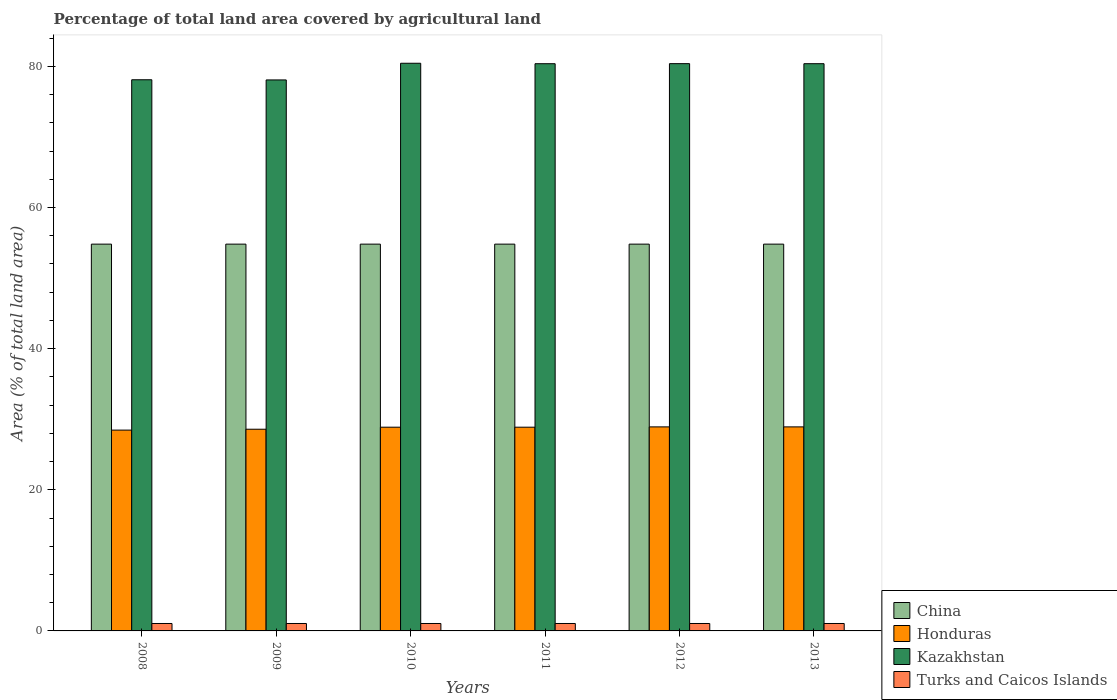How many different coloured bars are there?
Provide a short and direct response. 4. How many groups of bars are there?
Provide a succinct answer. 6. Are the number of bars per tick equal to the number of legend labels?
Give a very brief answer. Yes. In how many cases, is the number of bars for a given year not equal to the number of legend labels?
Your answer should be very brief. 0. What is the percentage of agricultural land in Kazakhstan in 2009?
Your response must be concise. 78.08. Across all years, what is the maximum percentage of agricultural land in China?
Make the answer very short. 54.81. Across all years, what is the minimum percentage of agricultural land in Honduras?
Ensure brevity in your answer.  28.46. What is the total percentage of agricultural land in Kazakhstan in the graph?
Your answer should be very brief. 477.75. What is the difference between the percentage of agricultural land in Kazakhstan in 2012 and the percentage of agricultural land in China in 2013?
Your answer should be compact. 25.58. What is the average percentage of agricultural land in Turks and Caicos Islands per year?
Provide a succinct answer. 1.05. In the year 2009, what is the difference between the percentage of agricultural land in Honduras and percentage of agricultural land in Kazakhstan?
Ensure brevity in your answer.  -49.49. In how many years, is the percentage of agricultural land in Honduras greater than 16 %?
Your answer should be very brief. 6. What is the ratio of the percentage of agricultural land in China in 2009 to that in 2012?
Your answer should be very brief. 1. Is the percentage of agricultural land in Turks and Caicos Islands in 2009 less than that in 2010?
Your response must be concise. No. What is the difference between the highest and the second highest percentage of agricultural land in Honduras?
Keep it short and to the point. 0. What is the difference between the highest and the lowest percentage of agricultural land in Kazakhstan?
Provide a succinct answer. 2.36. What does the 3rd bar from the left in 2009 represents?
Offer a very short reply. Kazakhstan. What does the 1st bar from the right in 2011 represents?
Your answer should be compact. Turks and Caicos Islands. How many bars are there?
Keep it short and to the point. 24. Are all the bars in the graph horizontal?
Make the answer very short. No. What is the difference between two consecutive major ticks on the Y-axis?
Your response must be concise. 20. Are the values on the major ticks of Y-axis written in scientific E-notation?
Your answer should be compact. No. Where does the legend appear in the graph?
Keep it short and to the point. Bottom right. How are the legend labels stacked?
Your response must be concise. Vertical. What is the title of the graph?
Make the answer very short. Percentage of total land area covered by agricultural land. Does "Luxembourg" appear as one of the legend labels in the graph?
Your response must be concise. No. What is the label or title of the X-axis?
Give a very brief answer. Years. What is the label or title of the Y-axis?
Give a very brief answer. Area (% of total land area). What is the Area (% of total land area) of China in 2008?
Keep it short and to the point. 54.81. What is the Area (% of total land area) in Honduras in 2008?
Offer a very short reply. 28.46. What is the Area (% of total land area) of Kazakhstan in 2008?
Your answer should be very brief. 78.1. What is the Area (% of total land area) in Turks and Caicos Islands in 2008?
Provide a succinct answer. 1.05. What is the Area (% of total land area) of China in 2009?
Ensure brevity in your answer.  54.81. What is the Area (% of total land area) of Honduras in 2009?
Keep it short and to the point. 28.58. What is the Area (% of total land area) in Kazakhstan in 2009?
Your response must be concise. 78.08. What is the Area (% of total land area) in Turks and Caicos Islands in 2009?
Offer a very short reply. 1.05. What is the Area (% of total land area) in China in 2010?
Offer a very short reply. 54.81. What is the Area (% of total land area) of Honduras in 2010?
Your answer should be compact. 28.87. What is the Area (% of total land area) of Kazakhstan in 2010?
Offer a terse response. 80.44. What is the Area (% of total land area) in Turks and Caicos Islands in 2010?
Give a very brief answer. 1.05. What is the Area (% of total land area) in China in 2011?
Keep it short and to the point. 54.81. What is the Area (% of total land area) of Honduras in 2011?
Offer a very short reply. 28.87. What is the Area (% of total land area) in Kazakhstan in 2011?
Provide a succinct answer. 80.38. What is the Area (% of total land area) in Turks and Caicos Islands in 2011?
Offer a terse response. 1.05. What is the Area (% of total land area) of China in 2012?
Keep it short and to the point. 54.81. What is the Area (% of total land area) of Honduras in 2012?
Your answer should be very brief. 28.91. What is the Area (% of total land area) in Kazakhstan in 2012?
Keep it short and to the point. 80.38. What is the Area (% of total land area) in Turks and Caicos Islands in 2012?
Give a very brief answer. 1.05. What is the Area (% of total land area) in China in 2013?
Provide a succinct answer. 54.81. What is the Area (% of total land area) of Honduras in 2013?
Make the answer very short. 28.91. What is the Area (% of total land area) of Kazakhstan in 2013?
Make the answer very short. 80.38. What is the Area (% of total land area) in Turks and Caicos Islands in 2013?
Ensure brevity in your answer.  1.05. Across all years, what is the maximum Area (% of total land area) in China?
Your answer should be compact. 54.81. Across all years, what is the maximum Area (% of total land area) in Honduras?
Offer a terse response. 28.91. Across all years, what is the maximum Area (% of total land area) of Kazakhstan?
Give a very brief answer. 80.44. Across all years, what is the maximum Area (% of total land area) of Turks and Caicos Islands?
Your answer should be compact. 1.05. Across all years, what is the minimum Area (% of total land area) in China?
Your answer should be compact. 54.81. Across all years, what is the minimum Area (% of total land area) in Honduras?
Provide a short and direct response. 28.46. Across all years, what is the minimum Area (% of total land area) of Kazakhstan?
Your response must be concise. 78.08. Across all years, what is the minimum Area (% of total land area) in Turks and Caicos Islands?
Offer a terse response. 1.05. What is the total Area (% of total land area) of China in the graph?
Ensure brevity in your answer.  328.85. What is the total Area (% of total land area) in Honduras in the graph?
Ensure brevity in your answer.  172.6. What is the total Area (% of total land area) in Kazakhstan in the graph?
Your response must be concise. 477.75. What is the total Area (% of total land area) in Turks and Caicos Islands in the graph?
Offer a terse response. 6.32. What is the difference between the Area (% of total land area) in China in 2008 and that in 2009?
Make the answer very short. -0. What is the difference between the Area (% of total land area) in Honduras in 2008 and that in 2009?
Keep it short and to the point. -0.13. What is the difference between the Area (% of total land area) of Kazakhstan in 2008 and that in 2009?
Provide a short and direct response. 0.03. What is the difference between the Area (% of total land area) of China in 2008 and that in 2010?
Keep it short and to the point. -0. What is the difference between the Area (% of total land area) in Honduras in 2008 and that in 2010?
Provide a short and direct response. -0.41. What is the difference between the Area (% of total land area) in Kazakhstan in 2008 and that in 2010?
Offer a very short reply. -2.34. What is the difference between the Area (% of total land area) of China in 2008 and that in 2011?
Provide a short and direct response. -0. What is the difference between the Area (% of total land area) in Honduras in 2008 and that in 2011?
Offer a terse response. -0.41. What is the difference between the Area (% of total land area) in Kazakhstan in 2008 and that in 2011?
Offer a very short reply. -2.27. What is the difference between the Area (% of total land area) in Turks and Caicos Islands in 2008 and that in 2011?
Ensure brevity in your answer.  0. What is the difference between the Area (% of total land area) of China in 2008 and that in 2012?
Give a very brief answer. -0. What is the difference between the Area (% of total land area) of Honduras in 2008 and that in 2012?
Your answer should be very brief. -0.46. What is the difference between the Area (% of total land area) in Kazakhstan in 2008 and that in 2012?
Give a very brief answer. -2.28. What is the difference between the Area (% of total land area) in China in 2008 and that in 2013?
Offer a terse response. -0. What is the difference between the Area (% of total land area) of Honduras in 2008 and that in 2013?
Provide a short and direct response. -0.46. What is the difference between the Area (% of total land area) in Kazakhstan in 2008 and that in 2013?
Your answer should be very brief. -2.28. What is the difference between the Area (% of total land area) of China in 2009 and that in 2010?
Provide a short and direct response. 0. What is the difference between the Area (% of total land area) of Honduras in 2009 and that in 2010?
Give a very brief answer. -0.29. What is the difference between the Area (% of total land area) of Kazakhstan in 2009 and that in 2010?
Your answer should be compact. -2.36. What is the difference between the Area (% of total land area) of Honduras in 2009 and that in 2011?
Offer a very short reply. -0.29. What is the difference between the Area (% of total land area) of Kazakhstan in 2009 and that in 2011?
Give a very brief answer. -2.3. What is the difference between the Area (% of total land area) in Turks and Caicos Islands in 2009 and that in 2011?
Make the answer very short. 0. What is the difference between the Area (% of total land area) of Honduras in 2009 and that in 2012?
Provide a succinct answer. -0.33. What is the difference between the Area (% of total land area) of Kazakhstan in 2009 and that in 2012?
Provide a succinct answer. -2.31. What is the difference between the Area (% of total land area) in China in 2009 and that in 2013?
Give a very brief answer. 0. What is the difference between the Area (% of total land area) of Honduras in 2009 and that in 2013?
Your response must be concise. -0.33. What is the difference between the Area (% of total land area) in Kazakhstan in 2009 and that in 2013?
Provide a short and direct response. -2.3. What is the difference between the Area (% of total land area) of Turks and Caicos Islands in 2009 and that in 2013?
Your answer should be very brief. 0. What is the difference between the Area (% of total land area) in China in 2010 and that in 2011?
Give a very brief answer. -0. What is the difference between the Area (% of total land area) in Honduras in 2010 and that in 2011?
Your answer should be very brief. 0. What is the difference between the Area (% of total land area) of Kazakhstan in 2010 and that in 2011?
Your answer should be very brief. 0.06. What is the difference between the Area (% of total land area) in China in 2010 and that in 2012?
Your answer should be very brief. -0. What is the difference between the Area (% of total land area) in Honduras in 2010 and that in 2012?
Give a very brief answer. -0.04. What is the difference between the Area (% of total land area) of Kazakhstan in 2010 and that in 2012?
Ensure brevity in your answer.  0.06. What is the difference between the Area (% of total land area) in Turks and Caicos Islands in 2010 and that in 2012?
Keep it short and to the point. 0. What is the difference between the Area (% of total land area) in China in 2010 and that in 2013?
Offer a terse response. -0. What is the difference between the Area (% of total land area) of Honduras in 2010 and that in 2013?
Ensure brevity in your answer.  -0.04. What is the difference between the Area (% of total land area) of Kazakhstan in 2010 and that in 2013?
Ensure brevity in your answer.  0.06. What is the difference between the Area (% of total land area) of Turks and Caicos Islands in 2010 and that in 2013?
Ensure brevity in your answer.  0. What is the difference between the Area (% of total land area) in China in 2011 and that in 2012?
Provide a succinct answer. 0. What is the difference between the Area (% of total land area) in Honduras in 2011 and that in 2012?
Your answer should be very brief. -0.04. What is the difference between the Area (% of total land area) in Kazakhstan in 2011 and that in 2012?
Ensure brevity in your answer.  -0.01. What is the difference between the Area (% of total land area) in Turks and Caicos Islands in 2011 and that in 2012?
Your answer should be compact. 0. What is the difference between the Area (% of total land area) in Honduras in 2011 and that in 2013?
Provide a succinct answer. -0.04. What is the difference between the Area (% of total land area) in Kazakhstan in 2011 and that in 2013?
Ensure brevity in your answer.  -0. What is the difference between the Area (% of total land area) of Turks and Caicos Islands in 2011 and that in 2013?
Provide a succinct answer. 0. What is the difference between the Area (% of total land area) of Kazakhstan in 2012 and that in 2013?
Your answer should be very brief. 0.01. What is the difference between the Area (% of total land area) of Turks and Caicos Islands in 2012 and that in 2013?
Offer a terse response. 0. What is the difference between the Area (% of total land area) in China in 2008 and the Area (% of total land area) in Honduras in 2009?
Provide a short and direct response. 26.23. What is the difference between the Area (% of total land area) of China in 2008 and the Area (% of total land area) of Kazakhstan in 2009?
Provide a short and direct response. -23.27. What is the difference between the Area (% of total land area) of China in 2008 and the Area (% of total land area) of Turks and Caicos Islands in 2009?
Make the answer very short. 53.76. What is the difference between the Area (% of total land area) of Honduras in 2008 and the Area (% of total land area) of Kazakhstan in 2009?
Provide a short and direct response. -49.62. What is the difference between the Area (% of total land area) of Honduras in 2008 and the Area (% of total land area) of Turks and Caicos Islands in 2009?
Keep it short and to the point. 27.4. What is the difference between the Area (% of total land area) in Kazakhstan in 2008 and the Area (% of total land area) in Turks and Caicos Islands in 2009?
Your answer should be very brief. 77.05. What is the difference between the Area (% of total land area) of China in 2008 and the Area (% of total land area) of Honduras in 2010?
Offer a very short reply. 25.94. What is the difference between the Area (% of total land area) in China in 2008 and the Area (% of total land area) in Kazakhstan in 2010?
Keep it short and to the point. -25.63. What is the difference between the Area (% of total land area) in China in 2008 and the Area (% of total land area) in Turks and Caicos Islands in 2010?
Your answer should be very brief. 53.76. What is the difference between the Area (% of total land area) of Honduras in 2008 and the Area (% of total land area) of Kazakhstan in 2010?
Offer a terse response. -51.98. What is the difference between the Area (% of total land area) of Honduras in 2008 and the Area (% of total land area) of Turks and Caicos Islands in 2010?
Your response must be concise. 27.4. What is the difference between the Area (% of total land area) of Kazakhstan in 2008 and the Area (% of total land area) of Turks and Caicos Islands in 2010?
Make the answer very short. 77.05. What is the difference between the Area (% of total land area) of China in 2008 and the Area (% of total land area) of Honduras in 2011?
Your answer should be compact. 25.94. What is the difference between the Area (% of total land area) in China in 2008 and the Area (% of total land area) in Kazakhstan in 2011?
Give a very brief answer. -25.57. What is the difference between the Area (% of total land area) in China in 2008 and the Area (% of total land area) in Turks and Caicos Islands in 2011?
Give a very brief answer. 53.76. What is the difference between the Area (% of total land area) in Honduras in 2008 and the Area (% of total land area) in Kazakhstan in 2011?
Offer a very short reply. -51.92. What is the difference between the Area (% of total land area) of Honduras in 2008 and the Area (% of total land area) of Turks and Caicos Islands in 2011?
Give a very brief answer. 27.4. What is the difference between the Area (% of total land area) in Kazakhstan in 2008 and the Area (% of total land area) in Turks and Caicos Islands in 2011?
Offer a very short reply. 77.05. What is the difference between the Area (% of total land area) of China in 2008 and the Area (% of total land area) of Honduras in 2012?
Provide a succinct answer. 25.9. What is the difference between the Area (% of total land area) in China in 2008 and the Area (% of total land area) in Kazakhstan in 2012?
Your response must be concise. -25.58. What is the difference between the Area (% of total land area) of China in 2008 and the Area (% of total land area) of Turks and Caicos Islands in 2012?
Keep it short and to the point. 53.76. What is the difference between the Area (% of total land area) of Honduras in 2008 and the Area (% of total land area) of Kazakhstan in 2012?
Your answer should be compact. -51.93. What is the difference between the Area (% of total land area) in Honduras in 2008 and the Area (% of total land area) in Turks and Caicos Islands in 2012?
Your response must be concise. 27.4. What is the difference between the Area (% of total land area) of Kazakhstan in 2008 and the Area (% of total land area) of Turks and Caicos Islands in 2012?
Provide a succinct answer. 77.05. What is the difference between the Area (% of total land area) of China in 2008 and the Area (% of total land area) of Honduras in 2013?
Provide a succinct answer. 25.9. What is the difference between the Area (% of total land area) of China in 2008 and the Area (% of total land area) of Kazakhstan in 2013?
Your response must be concise. -25.57. What is the difference between the Area (% of total land area) in China in 2008 and the Area (% of total land area) in Turks and Caicos Islands in 2013?
Make the answer very short. 53.76. What is the difference between the Area (% of total land area) of Honduras in 2008 and the Area (% of total land area) of Kazakhstan in 2013?
Make the answer very short. -51.92. What is the difference between the Area (% of total land area) in Honduras in 2008 and the Area (% of total land area) in Turks and Caicos Islands in 2013?
Make the answer very short. 27.4. What is the difference between the Area (% of total land area) in Kazakhstan in 2008 and the Area (% of total land area) in Turks and Caicos Islands in 2013?
Ensure brevity in your answer.  77.05. What is the difference between the Area (% of total land area) in China in 2009 and the Area (% of total land area) in Honduras in 2010?
Make the answer very short. 25.94. What is the difference between the Area (% of total land area) of China in 2009 and the Area (% of total land area) of Kazakhstan in 2010?
Offer a very short reply. -25.63. What is the difference between the Area (% of total land area) of China in 2009 and the Area (% of total land area) of Turks and Caicos Islands in 2010?
Keep it short and to the point. 53.76. What is the difference between the Area (% of total land area) in Honduras in 2009 and the Area (% of total land area) in Kazakhstan in 2010?
Keep it short and to the point. -51.86. What is the difference between the Area (% of total land area) in Honduras in 2009 and the Area (% of total land area) in Turks and Caicos Islands in 2010?
Ensure brevity in your answer.  27.53. What is the difference between the Area (% of total land area) of Kazakhstan in 2009 and the Area (% of total land area) of Turks and Caicos Islands in 2010?
Ensure brevity in your answer.  77.02. What is the difference between the Area (% of total land area) in China in 2009 and the Area (% of total land area) in Honduras in 2011?
Your response must be concise. 25.94. What is the difference between the Area (% of total land area) in China in 2009 and the Area (% of total land area) in Kazakhstan in 2011?
Provide a short and direct response. -25.57. What is the difference between the Area (% of total land area) of China in 2009 and the Area (% of total land area) of Turks and Caicos Islands in 2011?
Your answer should be very brief. 53.76. What is the difference between the Area (% of total land area) of Honduras in 2009 and the Area (% of total land area) of Kazakhstan in 2011?
Your answer should be compact. -51.79. What is the difference between the Area (% of total land area) of Honduras in 2009 and the Area (% of total land area) of Turks and Caicos Islands in 2011?
Your answer should be compact. 27.53. What is the difference between the Area (% of total land area) in Kazakhstan in 2009 and the Area (% of total land area) in Turks and Caicos Islands in 2011?
Make the answer very short. 77.02. What is the difference between the Area (% of total land area) of China in 2009 and the Area (% of total land area) of Honduras in 2012?
Make the answer very short. 25.9. What is the difference between the Area (% of total land area) in China in 2009 and the Area (% of total land area) in Kazakhstan in 2012?
Your answer should be compact. -25.58. What is the difference between the Area (% of total land area) in China in 2009 and the Area (% of total land area) in Turks and Caicos Islands in 2012?
Offer a very short reply. 53.76. What is the difference between the Area (% of total land area) in Honduras in 2009 and the Area (% of total land area) in Kazakhstan in 2012?
Offer a very short reply. -51.8. What is the difference between the Area (% of total land area) in Honduras in 2009 and the Area (% of total land area) in Turks and Caicos Islands in 2012?
Your answer should be compact. 27.53. What is the difference between the Area (% of total land area) in Kazakhstan in 2009 and the Area (% of total land area) in Turks and Caicos Islands in 2012?
Keep it short and to the point. 77.02. What is the difference between the Area (% of total land area) in China in 2009 and the Area (% of total land area) in Honduras in 2013?
Offer a very short reply. 25.9. What is the difference between the Area (% of total land area) of China in 2009 and the Area (% of total land area) of Kazakhstan in 2013?
Give a very brief answer. -25.57. What is the difference between the Area (% of total land area) in China in 2009 and the Area (% of total land area) in Turks and Caicos Islands in 2013?
Ensure brevity in your answer.  53.76. What is the difference between the Area (% of total land area) of Honduras in 2009 and the Area (% of total land area) of Kazakhstan in 2013?
Your answer should be compact. -51.8. What is the difference between the Area (% of total land area) of Honduras in 2009 and the Area (% of total land area) of Turks and Caicos Islands in 2013?
Offer a very short reply. 27.53. What is the difference between the Area (% of total land area) in Kazakhstan in 2009 and the Area (% of total land area) in Turks and Caicos Islands in 2013?
Provide a succinct answer. 77.02. What is the difference between the Area (% of total land area) in China in 2010 and the Area (% of total land area) in Honduras in 2011?
Provide a short and direct response. 25.94. What is the difference between the Area (% of total land area) in China in 2010 and the Area (% of total land area) in Kazakhstan in 2011?
Your answer should be very brief. -25.57. What is the difference between the Area (% of total land area) of China in 2010 and the Area (% of total land area) of Turks and Caicos Islands in 2011?
Your answer should be very brief. 53.76. What is the difference between the Area (% of total land area) of Honduras in 2010 and the Area (% of total land area) of Kazakhstan in 2011?
Provide a succinct answer. -51.51. What is the difference between the Area (% of total land area) of Honduras in 2010 and the Area (% of total land area) of Turks and Caicos Islands in 2011?
Provide a succinct answer. 27.82. What is the difference between the Area (% of total land area) in Kazakhstan in 2010 and the Area (% of total land area) in Turks and Caicos Islands in 2011?
Give a very brief answer. 79.39. What is the difference between the Area (% of total land area) in China in 2010 and the Area (% of total land area) in Honduras in 2012?
Provide a short and direct response. 25.9. What is the difference between the Area (% of total land area) in China in 2010 and the Area (% of total land area) in Kazakhstan in 2012?
Your answer should be very brief. -25.58. What is the difference between the Area (% of total land area) of China in 2010 and the Area (% of total land area) of Turks and Caicos Islands in 2012?
Offer a very short reply. 53.76. What is the difference between the Area (% of total land area) of Honduras in 2010 and the Area (% of total land area) of Kazakhstan in 2012?
Provide a short and direct response. -51.52. What is the difference between the Area (% of total land area) in Honduras in 2010 and the Area (% of total land area) in Turks and Caicos Islands in 2012?
Provide a short and direct response. 27.82. What is the difference between the Area (% of total land area) of Kazakhstan in 2010 and the Area (% of total land area) of Turks and Caicos Islands in 2012?
Your response must be concise. 79.39. What is the difference between the Area (% of total land area) of China in 2010 and the Area (% of total land area) of Honduras in 2013?
Offer a terse response. 25.9. What is the difference between the Area (% of total land area) of China in 2010 and the Area (% of total land area) of Kazakhstan in 2013?
Give a very brief answer. -25.57. What is the difference between the Area (% of total land area) of China in 2010 and the Area (% of total land area) of Turks and Caicos Islands in 2013?
Ensure brevity in your answer.  53.76. What is the difference between the Area (% of total land area) in Honduras in 2010 and the Area (% of total land area) in Kazakhstan in 2013?
Provide a short and direct response. -51.51. What is the difference between the Area (% of total land area) of Honduras in 2010 and the Area (% of total land area) of Turks and Caicos Islands in 2013?
Offer a terse response. 27.82. What is the difference between the Area (% of total land area) of Kazakhstan in 2010 and the Area (% of total land area) of Turks and Caicos Islands in 2013?
Your answer should be very brief. 79.39. What is the difference between the Area (% of total land area) in China in 2011 and the Area (% of total land area) in Honduras in 2012?
Your answer should be compact. 25.9. What is the difference between the Area (% of total land area) in China in 2011 and the Area (% of total land area) in Kazakhstan in 2012?
Provide a short and direct response. -25.58. What is the difference between the Area (% of total land area) of China in 2011 and the Area (% of total land area) of Turks and Caicos Islands in 2012?
Ensure brevity in your answer.  53.76. What is the difference between the Area (% of total land area) of Honduras in 2011 and the Area (% of total land area) of Kazakhstan in 2012?
Give a very brief answer. -51.52. What is the difference between the Area (% of total land area) in Honduras in 2011 and the Area (% of total land area) in Turks and Caicos Islands in 2012?
Provide a short and direct response. 27.82. What is the difference between the Area (% of total land area) of Kazakhstan in 2011 and the Area (% of total land area) of Turks and Caicos Islands in 2012?
Offer a very short reply. 79.32. What is the difference between the Area (% of total land area) of China in 2011 and the Area (% of total land area) of Honduras in 2013?
Keep it short and to the point. 25.9. What is the difference between the Area (% of total land area) of China in 2011 and the Area (% of total land area) of Kazakhstan in 2013?
Offer a very short reply. -25.57. What is the difference between the Area (% of total land area) in China in 2011 and the Area (% of total land area) in Turks and Caicos Islands in 2013?
Your response must be concise. 53.76. What is the difference between the Area (% of total land area) of Honduras in 2011 and the Area (% of total land area) of Kazakhstan in 2013?
Provide a succinct answer. -51.51. What is the difference between the Area (% of total land area) of Honduras in 2011 and the Area (% of total land area) of Turks and Caicos Islands in 2013?
Provide a short and direct response. 27.82. What is the difference between the Area (% of total land area) in Kazakhstan in 2011 and the Area (% of total land area) in Turks and Caicos Islands in 2013?
Your answer should be very brief. 79.32. What is the difference between the Area (% of total land area) in China in 2012 and the Area (% of total land area) in Honduras in 2013?
Keep it short and to the point. 25.9. What is the difference between the Area (% of total land area) of China in 2012 and the Area (% of total land area) of Kazakhstan in 2013?
Ensure brevity in your answer.  -25.57. What is the difference between the Area (% of total land area) of China in 2012 and the Area (% of total land area) of Turks and Caicos Islands in 2013?
Your response must be concise. 53.76. What is the difference between the Area (% of total land area) of Honduras in 2012 and the Area (% of total land area) of Kazakhstan in 2013?
Your answer should be very brief. -51.46. What is the difference between the Area (% of total land area) of Honduras in 2012 and the Area (% of total land area) of Turks and Caicos Islands in 2013?
Offer a very short reply. 27.86. What is the difference between the Area (% of total land area) of Kazakhstan in 2012 and the Area (% of total land area) of Turks and Caicos Islands in 2013?
Your answer should be compact. 79.33. What is the average Area (% of total land area) in China per year?
Your response must be concise. 54.81. What is the average Area (% of total land area) of Honduras per year?
Ensure brevity in your answer.  28.77. What is the average Area (% of total land area) in Kazakhstan per year?
Provide a short and direct response. 79.63. What is the average Area (% of total land area) of Turks and Caicos Islands per year?
Offer a very short reply. 1.05. In the year 2008, what is the difference between the Area (% of total land area) in China and Area (% of total land area) in Honduras?
Keep it short and to the point. 26.35. In the year 2008, what is the difference between the Area (% of total land area) in China and Area (% of total land area) in Kazakhstan?
Offer a terse response. -23.29. In the year 2008, what is the difference between the Area (% of total land area) of China and Area (% of total land area) of Turks and Caicos Islands?
Give a very brief answer. 53.76. In the year 2008, what is the difference between the Area (% of total land area) in Honduras and Area (% of total land area) in Kazakhstan?
Give a very brief answer. -49.65. In the year 2008, what is the difference between the Area (% of total land area) in Honduras and Area (% of total land area) in Turks and Caicos Islands?
Your answer should be very brief. 27.4. In the year 2008, what is the difference between the Area (% of total land area) of Kazakhstan and Area (% of total land area) of Turks and Caicos Islands?
Ensure brevity in your answer.  77.05. In the year 2009, what is the difference between the Area (% of total land area) in China and Area (% of total land area) in Honduras?
Provide a short and direct response. 26.23. In the year 2009, what is the difference between the Area (% of total land area) of China and Area (% of total land area) of Kazakhstan?
Provide a succinct answer. -23.27. In the year 2009, what is the difference between the Area (% of total land area) of China and Area (% of total land area) of Turks and Caicos Islands?
Provide a short and direct response. 53.76. In the year 2009, what is the difference between the Area (% of total land area) in Honduras and Area (% of total land area) in Kazakhstan?
Your answer should be very brief. -49.49. In the year 2009, what is the difference between the Area (% of total land area) of Honduras and Area (% of total land area) of Turks and Caicos Islands?
Your response must be concise. 27.53. In the year 2009, what is the difference between the Area (% of total land area) of Kazakhstan and Area (% of total land area) of Turks and Caicos Islands?
Make the answer very short. 77.02. In the year 2010, what is the difference between the Area (% of total land area) of China and Area (% of total land area) of Honduras?
Keep it short and to the point. 25.94. In the year 2010, what is the difference between the Area (% of total land area) in China and Area (% of total land area) in Kazakhstan?
Your answer should be compact. -25.63. In the year 2010, what is the difference between the Area (% of total land area) of China and Area (% of total land area) of Turks and Caicos Islands?
Provide a short and direct response. 53.76. In the year 2010, what is the difference between the Area (% of total land area) in Honduras and Area (% of total land area) in Kazakhstan?
Your response must be concise. -51.57. In the year 2010, what is the difference between the Area (% of total land area) in Honduras and Area (% of total land area) in Turks and Caicos Islands?
Keep it short and to the point. 27.82. In the year 2010, what is the difference between the Area (% of total land area) in Kazakhstan and Area (% of total land area) in Turks and Caicos Islands?
Your answer should be very brief. 79.39. In the year 2011, what is the difference between the Area (% of total land area) of China and Area (% of total land area) of Honduras?
Your response must be concise. 25.94. In the year 2011, what is the difference between the Area (% of total land area) of China and Area (% of total land area) of Kazakhstan?
Provide a succinct answer. -25.57. In the year 2011, what is the difference between the Area (% of total land area) in China and Area (% of total land area) in Turks and Caicos Islands?
Keep it short and to the point. 53.76. In the year 2011, what is the difference between the Area (% of total land area) in Honduras and Area (% of total land area) in Kazakhstan?
Keep it short and to the point. -51.51. In the year 2011, what is the difference between the Area (% of total land area) in Honduras and Area (% of total land area) in Turks and Caicos Islands?
Provide a succinct answer. 27.82. In the year 2011, what is the difference between the Area (% of total land area) in Kazakhstan and Area (% of total land area) in Turks and Caicos Islands?
Your response must be concise. 79.32. In the year 2012, what is the difference between the Area (% of total land area) of China and Area (% of total land area) of Honduras?
Keep it short and to the point. 25.9. In the year 2012, what is the difference between the Area (% of total land area) of China and Area (% of total land area) of Kazakhstan?
Ensure brevity in your answer.  -25.58. In the year 2012, what is the difference between the Area (% of total land area) in China and Area (% of total land area) in Turks and Caicos Islands?
Provide a succinct answer. 53.76. In the year 2012, what is the difference between the Area (% of total land area) of Honduras and Area (% of total land area) of Kazakhstan?
Keep it short and to the point. -51.47. In the year 2012, what is the difference between the Area (% of total land area) in Honduras and Area (% of total land area) in Turks and Caicos Islands?
Give a very brief answer. 27.86. In the year 2012, what is the difference between the Area (% of total land area) of Kazakhstan and Area (% of total land area) of Turks and Caicos Islands?
Offer a very short reply. 79.33. In the year 2013, what is the difference between the Area (% of total land area) in China and Area (% of total land area) in Honduras?
Your answer should be compact. 25.9. In the year 2013, what is the difference between the Area (% of total land area) of China and Area (% of total land area) of Kazakhstan?
Your response must be concise. -25.57. In the year 2013, what is the difference between the Area (% of total land area) of China and Area (% of total land area) of Turks and Caicos Islands?
Offer a very short reply. 53.76. In the year 2013, what is the difference between the Area (% of total land area) of Honduras and Area (% of total land area) of Kazakhstan?
Your answer should be compact. -51.46. In the year 2013, what is the difference between the Area (% of total land area) of Honduras and Area (% of total land area) of Turks and Caicos Islands?
Your answer should be compact. 27.86. In the year 2013, what is the difference between the Area (% of total land area) of Kazakhstan and Area (% of total land area) of Turks and Caicos Islands?
Provide a succinct answer. 79.32. What is the ratio of the Area (% of total land area) in China in 2008 to that in 2009?
Your response must be concise. 1. What is the ratio of the Area (% of total land area) in Turks and Caicos Islands in 2008 to that in 2009?
Your answer should be very brief. 1. What is the ratio of the Area (% of total land area) of China in 2008 to that in 2010?
Provide a succinct answer. 1. What is the ratio of the Area (% of total land area) in Honduras in 2008 to that in 2010?
Provide a short and direct response. 0.99. What is the ratio of the Area (% of total land area) in Kazakhstan in 2008 to that in 2010?
Offer a terse response. 0.97. What is the ratio of the Area (% of total land area) in Turks and Caicos Islands in 2008 to that in 2010?
Ensure brevity in your answer.  1. What is the ratio of the Area (% of total land area) of Honduras in 2008 to that in 2011?
Ensure brevity in your answer.  0.99. What is the ratio of the Area (% of total land area) of Kazakhstan in 2008 to that in 2011?
Your answer should be compact. 0.97. What is the ratio of the Area (% of total land area) of Turks and Caicos Islands in 2008 to that in 2011?
Ensure brevity in your answer.  1. What is the ratio of the Area (% of total land area) in Honduras in 2008 to that in 2012?
Give a very brief answer. 0.98. What is the ratio of the Area (% of total land area) in Kazakhstan in 2008 to that in 2012?
Make the answer very short. 0.97. What is the ratio of the Area (% of total land area) of China in 2008 to that in 2013?
Give a very brief answer. 1. What is the ratio of the Area (% of total land area) of Honduras in 2008 to that in 2013?
Your answer should be very brief. 0.98. What is the ratio of the Area (% of total land area) in Kazakhstan in 2008 to that in 2013?
Provide a succinct answer. 0.97. What is the ratio of the Area (% of total land area) in Honduras in 2009 to that in 2010?
Offer a terse response. 0.99. What is the ratio of the Area (% of total land area) in Kazakhstan in 2009 to that in 2010?
Your answer should be compact. 0.97. What is the ratio of the Area (% of total land area) in Honduras in 2009 to that in 2011?
Keep it short and to the point. 0.99. What is the ratio of the Area (% of total land area) of Kazakhstan in 2009 to that in 2011?
Offer a very short reply. 0.97. What is the ratio of the Area (% of total land area) of Turks and Caicos Islands in 2009 to that in 2011?
Provide a short and direct response. 1. What is the ratio of the Area (% of total land area) of China in 2009 to that in 2012?
Give a very brief answer. 1. What is the ratio of the Area (% of total land area) of Honduras in 2009 to that in 2012?
Your response must be concise. 0.99. What is the ratio of the Area (% of total land area) in Kazakhstan in 2009 to that in 2012?
Ensure brevity in your answer.  0.97. What is the ratio of the Area (% of total land area) of China in 2009 to that in 2013?
Provide a short and direct response. 1. What is the ratio of the Area (% of total land area) in Honduras in 2009 to that in 2013?
Ensure brevity in your answer.  0.99. What is the ratio of the Area (% of total land area) in Kazakhstan in 2009 to that in 2013?
Offer a very short reply. 0.97. What is the ratio of the Area (% of total land area) in Turks and Caicos Islands in 2009 to that in 2013?
Offer a terse response. 1. What is the ratio of the Area (% of total land area) in Turks and Caicos Islands in 2010 to that in 2011?
Ensure brevity in your answer.  1. What is the ratio of the Area (% of total land area) of Turks and Caicos Islands in 2010 to that in 2013?
Keep it short and to the point. 1. What is the ratio of the Area (% of total land area) of Honduras in 2011 to that in 2012?
Provide a short and direct response. 1. What is the ratio of the Area (% of total land area) in Turks and Caicos Islands in 2011 to that in 2012?
Make the answer very short. 1. What is the ratio of the Area (% of total land area) in Honduras in 2011 to that in 2013?
Keep it short and to the point. 1. What is the ratio of the Area (% of total land area) in Kazakhstan in 2011 to that in 2013?
Ensure brevity in your answer.  1. What is the ratio of the Area (% of total land area) in Honduras in 2012 to that in 2013?
Keep it short and to the point. 1. What is the ratio of the Area (% of total land area) of Kazakhstan in 2012 to that in 2013?
Offer a very short reply. 1. What is the difference between the highest and the second highest Area (% of total land area) in China?
Provide a succinct answer. 0. What is the difference between the highest and the second highest Area (% of total land area) in Honduras?
Your answer should be very brief. 0. What is the difference between the highest and the second highest Area (% of total land area) in Kazakhstan?
Make the answer very short. 0.06. What is the difference between the highest and the lowest Area (% of total land area) in China?
Provide a succinct answer. 0. What is the difference between the highest and the lowest Area (% of total land area) of Honduras?
Your answer should be compact. 0.46. What is the difference between the highest and the lowest Area (% of total land area) of Kazakhstan?
Your answer should be very brief. 2.36. 